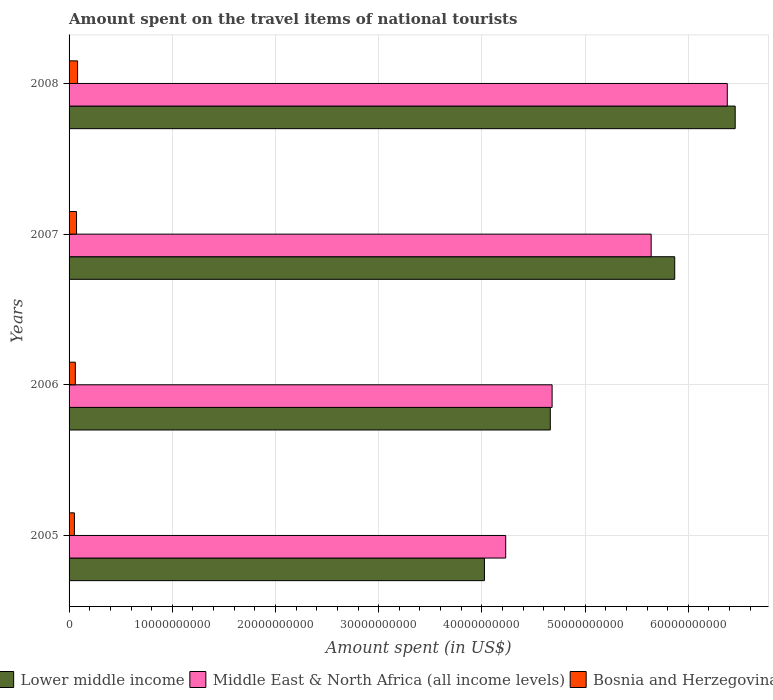How many groups of bars are there?
Give a very brief answer. 4. How many bars are there on the 4th tick from the bottom?
Offer a terse response. 3. In how many cases, is the number of bars for a given year not equal to the number of legend labels?
Provide a succinct answer. 0. What is the amount spent on the travel items of national tourists in Bosnia and Herzegovina in 2007?
Your answer should be compact. 7.24e+08. Across all years, what is the maximum amount spent on the travel items of national tourists in Lower middle income?
Ensure brevity in your answer.  6.45e+1. Across all years, what is the minimum amount spent on the travel items of national tourists in Bosnia and Herzegovina?
Give a very brief answer. 5.19e+08. What is the total amount spent on the travel items of national tourists in Lower middle income in the graph?
Offer a terse response. 2.10e+11. What is the difference between the amount spent on the travel items of national tourists in Bosnia and Herzegovina in 2006 and that in 2007?
Give a very brief answer. -1.17e+08. What is the difference between the amount spent on the travel items of national tourists in Bosnia and Herzegovina in 2006 and the amount spent on the travel items of national tourists in Middle East & North Africa (all income levels) in 2008?
Offer a terse response. -6.32e+1. What is the average amount spent on the travel items of national tourists in Lower middle income per year?
Make the answer very short. 5.25e+1. In the year 2006, what is the difference between the amount spent on the travel items of national tourists in Lower middle income and amount spent on the travel items of national tourists in Middle East & North Africa (all income levels)?
Offer a terse response. -1.76e+08. In how many years, is the amount spent on the travel items of national tourists in Middle East & North Africa (all income levels) greater than 44000000000 US$?
Your answer should be compact. 3. What is the ratio of the amount spent on the travel items of national tourists in Bosnia and Herzegovina in 2006 to that in 2007?
Keep it short and to the point. 0.84. What is the difference between the highest and the second highest amount spent on the travel items of national tourists in Middle East & North Africa (all income levels)?
Give a very brief answer. 7.37e+09. What is the difference between the highest and the lowest amount spent on the travel items of national tourists in Middle East & North Africa (all income levels)?
Your answer should be compact. 2.15e+1. What does the 2nd bar from the top in 2007 represents?
Your answer should be compact. Middle East & North Africa (all income levels). What does the 1st bar from the bottom in 2008 represents?
Ensure brevity in your answer.  Lower middle income. Is it the case that in every year, the sum of the amount spent on the travel items of national tourists in Middle East & North Africa (all income levels) and amount spent on the travel items of national tourists in Bosnia and Herzegovina is greater than the amount spent on the travel items of national tourists in Lower middle income?
Your answer should be compact. No. How many bars are there?
Provide a succinct answer. 12. What is the difference between two consecutive major ticks on the X-axis?
Offer a terse response. 1.00e+1. Are the values on the major ticks of X-axis written in scientific E-notation?
Offer a very short reply. No. Does the graph contain any zero values?
Your answer should be compact. No. Does the graph contain grids?
Your response must be concise. Yes. How many legend labels are there?
Make the answer very short. 3. How are the legend labels stacked?
Offer a terse response. Horizontal. What is the title of the graph?
Make the answer very short. Amount spent on the travel items of national tourists. Does "Bulgaria" appear as one of the legend labels in the graph?
Provide a succinct answer. No. What is the label or title of the X-axis?
Give a very brief answer. Amount spent (in US$). What is the label or title of the Y-axis?
Keep it short and to the point. Years. What is the Amount spent (in US$) in Lower middle income in 2005?
Provide a short and direct response. 4.02e+1. What is the Amount spent (in US$) of Middle East & North Africa (all income levels) in 2005?
Provide a succinct answer. 4.23e+1. What is the Amount spent (in US$) in Bosnia and Herzegovina in 2005?
Your answer should be very brief. 5.19e+08. What is the Amount spent (in US$) of Lower middle income in 2006?
Provide a succinct answer. 4.66e+1. What is the Amount spent (in US$) in Middle East & North Africa (all income levels) in 2006?
Provide a short and direct response. 4.68e+1. What is the Amount spent (in US$) of Bosnia and Herzegovina in 2006?
Your answer should be compact. 6.07e+08. What is the Amount spent (in US$) in Lower middle income in 2007?
Make the answer very short. 5.87e+1. What is the Amount spent (in US$) of Middle East & North Africa (all income levels) in 2007?
Keep it short and to the point. 5.64e+1. What is the Amount spent (in US$) in Bosnia and Herzegovina in 2007?
Provide a short and direct response. 7.24e+08. What is the Amount spent (in US$) in Lower middle income in 2008?
Your response must be concise. 6.45e+1. What is the Amount spent (in US$) of Middle East & North Africa (all income levels) in 2008?
Offer a very short reply. 6.38e+1. What is the Amount spent (in US$) of Bosnia and Herzegovina in 2008?
Your response must be concise. 8.25e+08. Across all years, what is the maximum Amount spent (in US$) in Lower middle income?
Provide a succinct answer. 6.45e+1. Across all years, what is the maximum Amount spent (in US$) of Middle East & North Africa (all income levels)?
Offer a terse response. 6.38e+1. Across all years, what is the maximum Amount spent (in US$) of Bosnia and Herzegovina?
Offer a terse response. 8.25e+08. Across all years, what is the minimum Amount spent (in US$) of Lower middle income?
Your answer should be compact. 4.02e+1. Across all years, what is the minimum Amount spent (in US$) of Middle East & North Africa (all income levels)?
Provide a short and direct response. 4.23e+1. Across all years, what is the minimum Amount spent (in US$) of Bosnia and Herzegovina?
Offer a terse response. 5.19e+08. What is the total Amount spent (in US$) of Lower middle income in the graph?
Your answer should be very brief. 2.10e+11. What is the total Amount spent (in US$) of Middle East & North Africa (all income levels) in the graph?
Provide a succinct answer. 2.09e+11. What is the total Amount spent (in US$) in Bosnia and Herzegovina in the graph?
Give a very brief answer. 2.68e+09. What is the difference between the Amount spent (in US$) of Lower middle income in 2005 and that in 2006?
Offer a terse response. -6.38e+09. What is the difference between the Amount spent (in US$) in Middle East & North Africa (all income levels) in 2005 and that in 2006?
Keep it short and to the point. -4.50e+09. What is the difference between the Amount spent (in US$) in Bosnia and Herzegovina in 2005 and that in 2006?
Your response must be concise. -8.80e+07. What is the difference between the Amount spent (in US$) of Lower middle income in 2005 and that in 2007?
Offer a very short reply. -1.84e+1. What is the difference between the Amount spent (in US$) of Middle East & North Africa (all income levels) in 2005 and that in 2007?
Give a very brief answer. -1.41e+1. What is the difference between the Amount spent (in US$) in Bosnia and Herzegovina in 2005 and that in 2007?
Provide a short and direct response. -2.05e+08. What is the difference between the Amount spent (in US$) in Lower middle income in 2005 and that in 2008?
Keep it short and to the point. -2.43e+1. What is the difference between the Amount spent (in US$) in Middle East & North Africa (all income levels) in 2005 and that in 2008?
Your response must be concise. -2.15e+1. What is the difference between the Amount spent (in US$) of Bosnia and Herzegovina in 2005 and that in 2008?
Offer a terse response. -3.06e+08. What is the difference between the Amount spent (in US$) in Lower middle income in 2006 and that in 2007?
Provide a short and direct response. -1.21e+1. What is the difference between the Amount spent (in US$) in Middle East & North Africa (all income levels) in 2006 and that in 2007?
Ensure brevity in your answer.  -9.60e+09. What is the difference between the Amount spent (in US$) of Bosnia and Herzegovina in 2006 and that in 2007?
Your answer should be very brief. -1.17e+08. What is the difference between the Amount spent (in US$) in Lower middle income in 2006 and that in 2008?
Keep it short and to the point. -1.79e+1. What is the difference between the Amount spent (in US$) in Middle East & North Africa (all income levels) in 2006 and that in 2008?
Offer a very short reply. -1.70e+1. What is the difference between the Amount spent (in US$) in Bosnia and Herzegovina in 2006 and that in 2008?
Offer a terse response. -2.18e+08. What is the difference between the Amount spent (in US$) in Lower middle income in 2007 and that in 2008?
Your answer should be compact. -5.86e+09. What is the difference between the Amount spent (in US$) in Middle East & North Africa (all income levels) in 2007 and that in 2008?
Ensure brevity in your answer.  -7.37e+09. What is the difference between the Amount spent (in US$) of Bosnia and Herzegovina in 2007 and that in 2008?
Provide a succinct answer. -1.01e+08. What is the difference between the Amount spent (in US$) of Lower middle income in 2005 and the Amount spent (in US$) of Middle East & North Africa (all income levels) in 2006?
Provide a short and direct response. -6.56e+09. What is the difference between the Amount spent (in US$) in Lower middle income in 2005 and the Amount spent (in US$) in Bosnia and Herzegovina in 2006?
Make the answer very short. 3.96e+1. What is the difference between the Amount spent (in US$) of Middle East & North Africa (all income levels) in 2005 and the Amount spent (in US$) of Bosnia and Herzegovina in 2006?
Keep it short and to the point. 4.17e+1. What is the difference between the Amount spent (in US$) in Lower middle income in 2005 and the Amount spent (in US$) in Middle East & North Africa (all income levels) in 2007?
Offer a very short reply. -1.62e+1. What is the difference between the Amount spent (in US$) of Lower middle income in 2005 and the Amount spent (in US$) of Bosnia and Herzegovina in 2007?
Provide a short and direct response. 3.95e+1. What is the difference between the Amount spent (in US$) of Middle East & North Africa (all income levels) in 2005 and the Amount spent (in US$) of Bosnia and Herzegovina in 2007?
Your answer should be very brief. 4.16e+1. What is the difference between the Amount spent (in US$) of Lower middle income in 2005 and the Amount spent (in US$) of Middle East & North Africa (all income levels) in 2008?
Your answer should be very brief. -2.35e+1. What is the difference between the Amount spent (in US$) in Lower middle income in 2005 and the Amount spent (in US$) in Bosnia and Herzegovina in 2008?
Give a very brief answer. 3.94e+1. What is the difference between the Amount spent (in US$) in Middle East & North Africa (all income levels) in 2005 and the Amount spent (in US$) in Bosnia and Herzegovina in 2008?
Offer a very short reply. 4.15e+1. What is the difference between the Amount spent (in US$) of Lower middle income in 2006 and the Amount spent (in US$) of Middle East & North Africa (all income levels) in 2007?
Give a very brief answer. -9.77e+09. What is the difference between the Amount spent (in US$) of Lower middle income in 2006 and the Amount spent (in US$) of Bosnia and Herzegovina in 2007?
Make the answer very short. 4.59e+1. What is the difference between the Amount spent (in US$) in Middle East & North Africa (all income levels) in 2006 and the Amount spent (in US$) in Bosnia and Herzegovina in 2007?
Provide a succinct answer. 4.61e+1. What is the difference between the Amount spent (in US$) of Lower middle income in 2006 and the Amount spent (in US$) of Middle East & North Africa (all income levels) in 2008?
Ensure brevity in your answer.  -1.71e+1. What is the difference between the Amount spent (in US$) in Lower middle income in 2006 and the Amount spent (in US$) in Bosnia and Herzegovina in 2008?
Provide a succinct answer. 4.58e+1. What is the difference between the Amount spent (in US$) in Middle East & North Africa (all income levels) in 2006 and the Amount spent (in US$) in Bosnia and Herzegovina in 2008?
Give a very brief answer. 4.60e+1. What is the difference between the Amount spent (in US$) in Lower middle income in 2007 and the Amount spent (in US$) in Middle East & North Africa (all income levels) in 2008?
Ensure brevity in your answer.  -5.09e+09. What is the difference between the Amount spent (in US$) of Lower middle income in 2007 and the Amount spent (in US$) of Bosnia and Herzegovina in 2008?
Provide a short and direct response. 5.79e+1. What is the difference between the Amount spent (in US$) in Middle East & North Africa (all income levels) in 2007 and the Amount spent (in US$) in Bosnia and Herzegovina in 2008?
Provide a short and direct response. 5.56e+1. What is the average Amount spent (in US$) of Lower middle income per year?
Your response must be concise. 5.25e+1. What is the average Amount spent (in US$) of Middle East & North Africa (all income levels) per year?
Offer a terse response. 5.23e+1. What is the average Amount spent (in US$) in Bosnia and Herzegovina per year?
Keep it short and to the point. 6.69e+08. In the year 2005, what is the difference between the Amount spent (in US$) in Lower middle income and Amount spent (in US$) in Middle East & North Africa (all income levels)?
Give a very brief answer. -2.06e+09. In the year 2005, what is the difference between the Amount spent (in US$) in Lower middle income and Amount spent (in US$) in Bosnia and Herzegovina?
Give a very brief answer. 3.97e+1. In the year 2005, what is the difference between the Amount spent (in US$) of Middle East & North Africa (all income levels) and Amount spent (in US$) of Bosnia and Herzegovina?
Offer a very short reply. 4.18e+1. In the year 2006, what is the difference between the Amount spent (in US$) in Lower middle income and Amount spent (in US$) in Middle East & North Africa (all income levels)?
Give a very brief answer. -1.76e+08. In the year 2006, what is the difference between the Amount spent (in US$) of Lower middle income and Amount spent (in US$) of Bosnia and Herzegovina?
Ensure brevity in your answer.  4.60e+1. In the year 2006, what is the difference between the Amount spent (in US$) in Middle East & North Africa (all income levels) and Amount spent (in US$) in Bosnia and Herzegovina?
Your answer should be compact. 4.62e+1. In the year 2007, what is the difference between the Amount spent (in US$) of Lower middle income and Amount spent (in US$) of Middle East & North Africa (all income levels)?
Provide a succinct answer. 2.28e+09. In the year 2007, what is the difference between the Amount spent (in US$) in Lower middle income and Amount spent (in US$) in Bosnia and Herzegovina?
Ensure brevity in your answer.  5.80e+1. In the year 2007, what is the difference between the Amount spent (in US$) in Middle East & North Africa (all income levels) and Amount spent (in US$) in Bosnia and Herzegovina?
Your answer should be compact. 5.57e+1. In the year 2008, what is the difference between the Amount spent (in US$) in Lower middle income and Amount spent (in US$) in Middle East & North Africa (all income levels)?
Offer a terse response. 7.65e+08. In the year 2008, what is the difference between the Amount spent (in US$) in Lower middle income and Amount spent (in US$) in Bosnia and Herzegovina?
Offer a terse response. 6.37e+1. In the year 2008, what is the difference between the Amount spent (in US$) in Middle East & North Africa (all income levels) and Amount spent (in US$) in Bosnia and Herzegovina?
Your answer should be very brief. 6.30e+1. What is the ratio of the Amount spent (in US$) of Lower middle income in 2005 to that in 2006?
Your answer should be very brief. 0.86. What is the ratio of the Amount spent (in US$) in Middle East & North Africa (all income levels) in 2005 to that in 2006?
Provide a short and direct response. 0.9. What is the ratio of the Amount spent (in US$) of Bosnia and Herzegovina in 2005 to that in 2006?
Provide a succinct answer. 0.85. What is the ratio of the Amount spent (in US$) in Lower middle income in 2005 to that in 2007?
Ensure brevity in your answer.  0.69. What is the ratio of the Amount spent (in US$) of Middle East & North Africa (all income levels) in 2005 to that in 2007?
Ensure brevity in your answer.  0.75. What is the ratio of the Amount spent (in US$) in Bosnia and Herzegovina in 2005 to that in 2007?
Your response must be concise. 0.72. What is the ratio of the Amount spent (in US$) in Lower middle income in 2005 to that in 2008?
Ensure brevity in your answer.  0.62. What is the ratio of the Amount spent (in US$) of Middle East & North Africa (all income levels) in 2005 to that in 2008?
Your answer should be compact. 0.66. What is the ratio of the Amount spent (in US$) of Bosnia and Herzegovina in 2005 to that in 2008?
Your response must be concise. 0.63. What is the ratio of the Amount spent (in US$) of Lower middle income in 2006 to that in 2007?
Offer a terse response. 0.79. What is the ratio of the Amount spent (in US$) of Middle East & North Africa (all income levels) in 2006 to that in 2007?
Provide a succinct answer. 0.83. What is the ratio of the Amount spent (in US$) of Bosnia and Herzegovina in 2006 to that in 2007?
Provide a succinct answer. 0.84. What is the ratio of the Amount spent (in US$) of Lower middle income in 2006 to that in 2008?
Ensure brevity in your answer.  0.72. What is the ratio of the Amount spent (in US$) of Middle East & North Africa (all income levels) in 2006 to that in 2008?
Keep it short and to the point. 0.73. What is the ratio of the Amount spent (in US$) in Bosnia and Herzegovina in 2006 to that in 2008?
Make the answer very short. 0.74. What is the ratio of the Amount spent (in US$) in Lower middle income in 2007 to that in 2008?
Provide a short and direct response. 0.91. What is the ratio of the Amount spent (in US$) of Middle East & North Africa (all income levels) in 2007 to that in 2008?
Keep it short and to the point. 0.88. What is the ratio of the Amount spent (in US$) in Bosnia and Herzegovina in 2007 to that in 2008?
Ensure brevity in your answer.  0.88. What is the difference between the highest and the second highest Amount spent (in US$) in Lower middle income?
Keep it short and to the point. 5.86e+09. What is the difference between the highest and the second highest Amount spent (in US$) of Middle East & North Africa (all income levels)?
Offer a terse response. 7.37e+09. What is the difference between the highest and the second highest Amount spent (in US$) in Bosnia and Herzegovina?
Ensure brevity in your answer.  1.01e+08. What is the difference between the highest and the lowest Amount spent (in US$) of Lower middle income?
Offer a very short reply. 2.43e+1. What is the difference between the highest and the lowest Amount spent (in US$) of Middle East & North Africa (all income levels)?
Your answer should be compact. 2.15e+1. What is the difference between the highest and the lowest Amount spent (in US$) of Bosnia and Herzegovina?
Your response must be concise. 3.06e+08. 